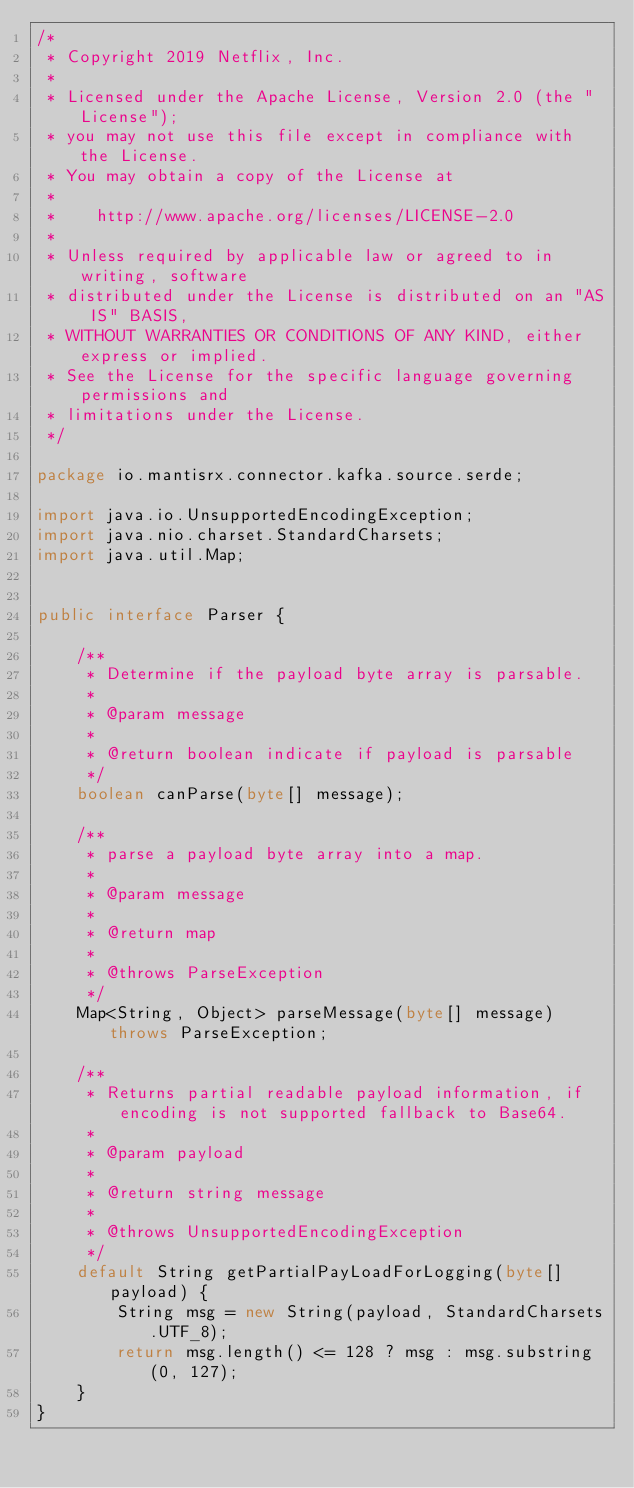<code> <loc_0><loc_0><loc_500><loc_500><_Java_>/*
 * Copyright 2019 Netflix, Inc.
 *
 * Licensed under the Apache License, Version 2.0 (the "License");
 * you may not use this file except in compliance with the License.
 * You may obtain a copy of the License at
 *
 *    http://www.apache.org/licenses/LICENSE-2.0
 *
 * Unless required by applicable law or agreed to in writing, software
 * distributed under the License is distributed on an "AS IS" BASIS,
 * WITHOUT WARRANTIES OR CONDITIONS OF ANY KIND, either express or implied.
 * See the License for the specific language governing permissions and
 * limitations under the License.
 */

package io.mantisrx.connector.kafka.source.serde;

import java.io.UnsupportedEncodingException;
import java.nio.charset.StandardCharsets;
import java.util.Map;


public interface Parser {

    /**
     * Determine if the payload byte array is parsable.
     *
     * @param message
     *
     * @return boolean indicate if payload is parsable
     */
    boolean canParse(byte[] message);

    /**
     * parse a payload byte array into a map.
     *
     * @param message
     *
     * @return map
     *
     * @throws ParseException
     */
    Map<String, Object> parseMessage(byte[] message) throws ParseException;

    /**
     * Returns partial readable payload information, if encoding is not supported fallback to Base64.
     *
     * @param payload
     *
     * @return string message
     *
     * @throws UnsupportedEncodingException
     */
    default String getPartialPayLoadForLogging(byte[] payload) {
        String msg = new String(payload, StandardCharsets.UTF_8);
        return msg.length() <= 128 ? msg : msg.substring(0, 127);
    }
}
</code> 